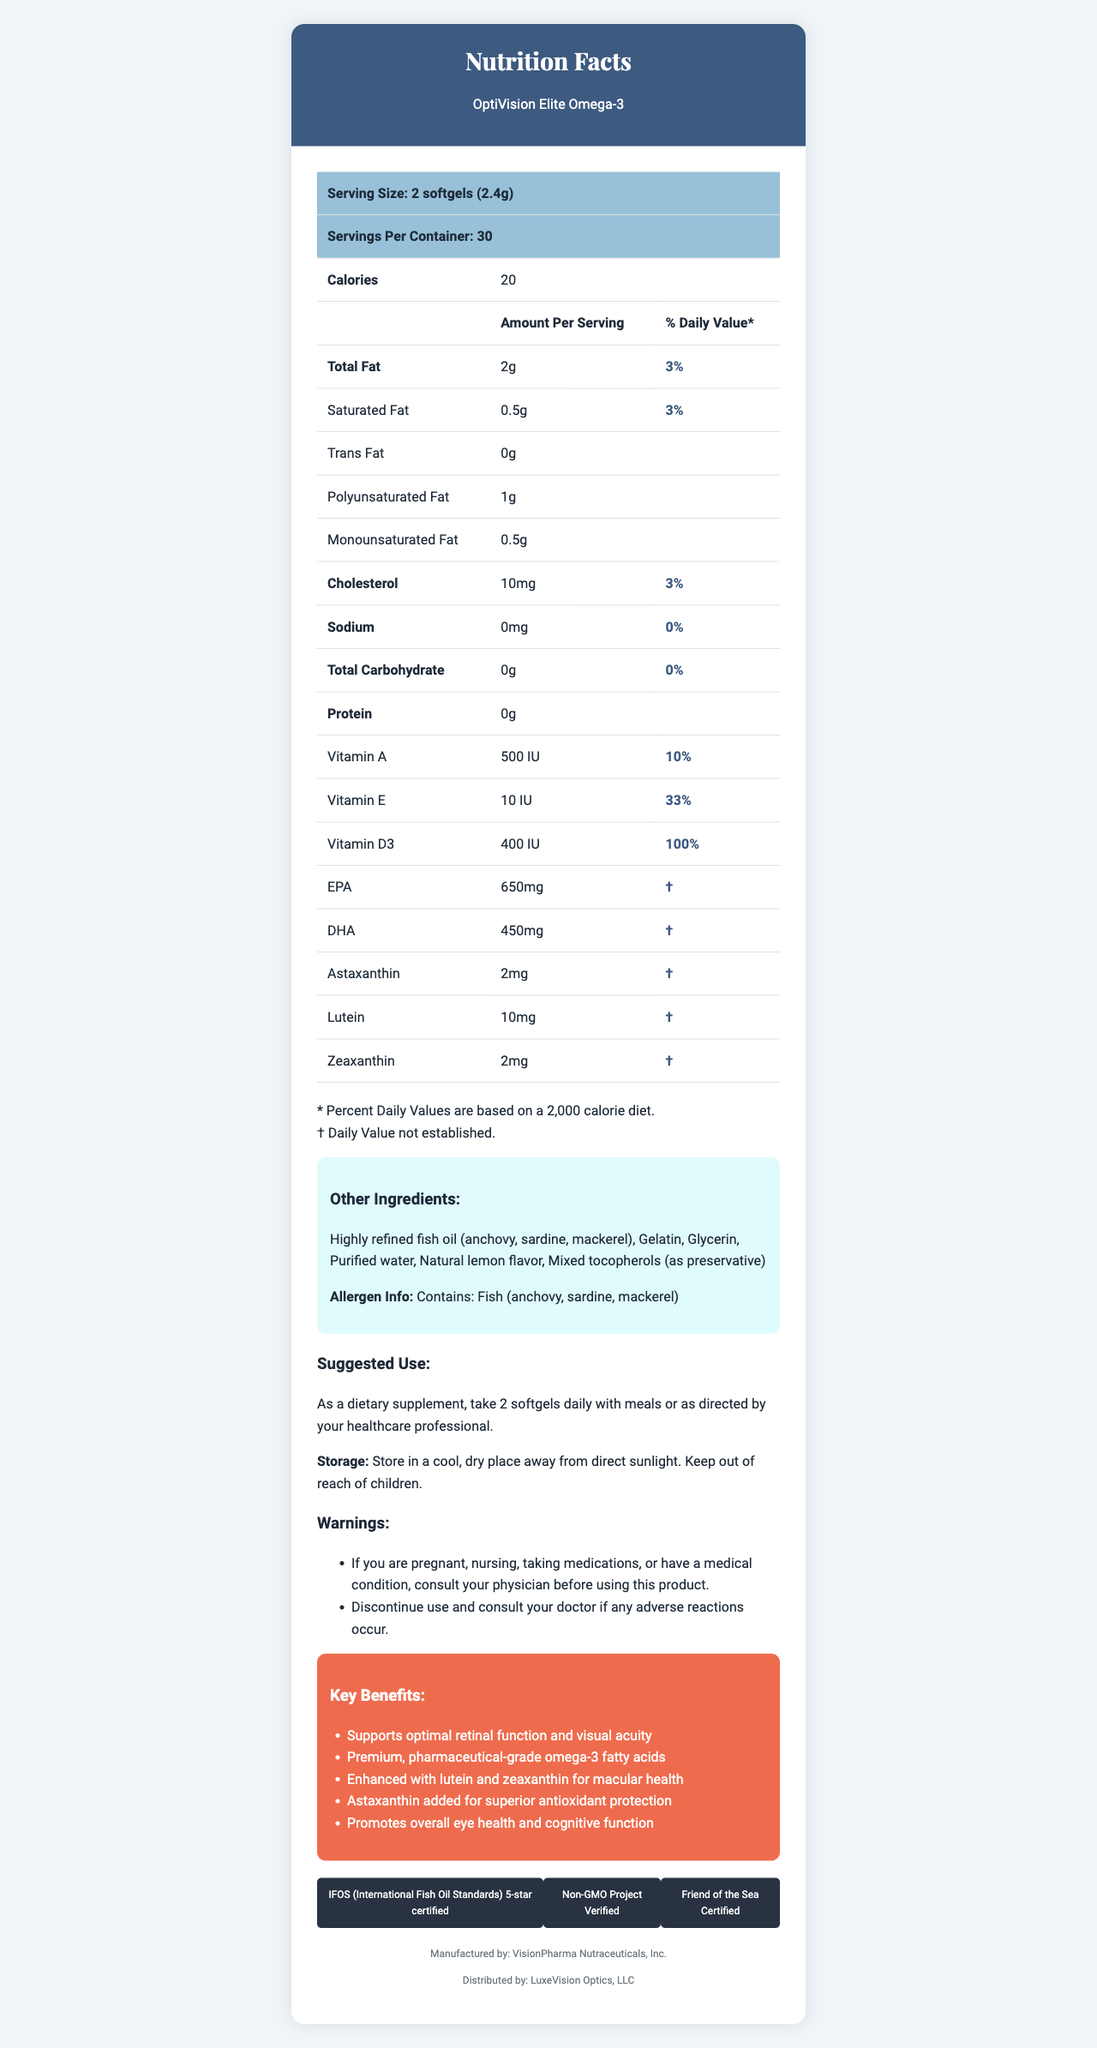what is the serving size for OptiVision Elite Omega-3? The serving size is explicitly listed in the document as "2 softgels (2.4g)".
Answer: 2 softgels (2.4g) how many servings are there per container? The document states that there are 30 servings per container.
Answer: 30 how many calories are there per serving? The document lists the calories per serving as 20.
Answer: 20 what is the total fat content per serving, and what percentage of the daily value does it represent? The document shows that the total fat content per serving is 2 grams, which represents 3% of the daily value.
Answer: 2g, 3% what is the daily value percentage of vitamin D3 per serving? The daily value percentage of vitamin D3 per serving is 100%, as specified in the document.
Answer: 100% which ingredient in the list of other ingredients serves as a preservative? The document lists "Mixed tocopherols (as preservative)" among the other ingredients.
Answer: Mixed tocopherols what is the cholesterol content per serving? The document states that the cholesterol content per serving is 10mg.
Answer: 10mg vitamin A is present in what amount and what percentage of the daily value? The document lists 500 IU of Vitamin A, which is 10% of the daily value.
Answer: 500 IU, 10% how much EPA is in each serving of OptiVision Elite Omega-3? The document specifies that each serving contains 650mg of EPA.
Answer: 650mg which of the following is not mentioned in the list of certifications? A. IFOS 5-star B. USDA Organic C. Non-GMO Project Verified The document lists IFOS 5-star certified, Non-GMO Project Verified, and Friend of the Sea Certified. USDA Organic is not mentioned.
Answer: B what are the key benefits of OptiVision Elite Omega-3? A. Supports retinal function B. Supports heart health C. Enhances cognitive function D. Promotes muscle growth E. Superior antioxidant protection The document claims: Supports optimal retinal function, enhanced cognitive function, and superior antioxidant protection. It does not mention heart health or muscle growth.
Answer: A, C, E if someone is pregnant, should they use this product without consulting a physician? Yes/No The document includes a warning: "If you are pregnant, nursing, taking medications, or have a medical condition, consult your physician before using this product."
Answer: No summarize the main nutritional benefits and features of OptiVision Elite Omega-3 described in the document The document highlights the product's nutritional composition, including omega-3 fatty acids, vitamins, and antioxidants, and emphasizes certifications indicating high-quality standards.
Answer: OptiVision Elite Omega-3 is designed to support optimal retinal function and visual acuity, enhanced with lutein and zeaxanthin for macular health, and astaxanthin for antioxidant protection. It contains pharmaceutical-grade omega-3 fatty acids and key vitamins like A, E, and D3. The product is also certified by IFOS (5-star), Non-GMO Project Verified, and Friend of the Sea Certified. how many milligrams of DHA does each serving provide? The document specifies that each serving provides 450mg of DHA.
Answer: 450mg does the product contain any allergens? The document clearly states that the product contains fish (anchovy, sardine, mackerel) in the allergen info section.
Answer: Yes, fish (anchovy, sardine, mackerel) what is the amount of lutein per serving and the associated daily value percentage? The document lists 10mg of lutein per serving but notes a "†" indicating the daily value is not established.
Answer: 10mg, daily value not established does the nutrition label specify the impact of this product on visual health? The document includes marketing claims that specifically mention the product supports optimal retinal function and visual acuity.
Answer: Yes, the marketing claims state that it supports optimal retinal function and visual acuity. what should you do if you have an adverse reaction to this product? The document provides a warning: "Discontinue use and consult your doctor if any adverse reactions occur."
Answer: Discontinue use and consult your doctor what is the source of the highly refined fish oil used in OptiVision Elite Omega-3? The document lists the source of the fish oil in the other ingredients section as anchovy, sardine, and mackerel.
Answer: Anchovy, sardine, mackerel what is the total number of carbohydrates per serving, and what is its percent daily value? The document indicates that total carbohydrates per serving are 0 grams, which is 0% of the daily value.
Answer: 0g, 0% what is the shelf life or expiration date of OptiVision Elite Omega-3? The document does not provide any information regarding the shelf life or expiration date of the product.
Answer: Cannot be determined 